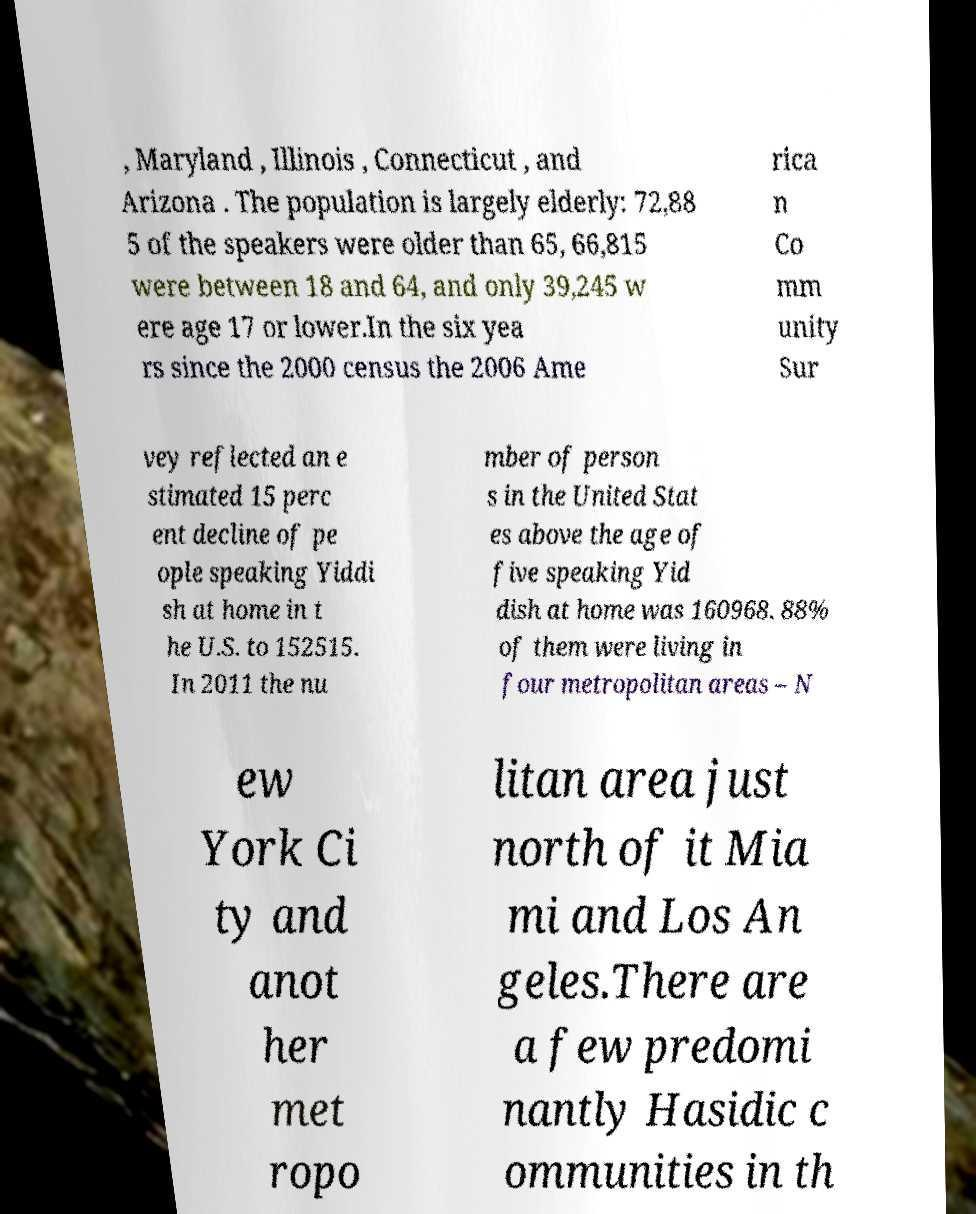Could you extract and type out the text from this image? , Maryland , Illinois , Connecticut , and Arizona . The population is largely elderly: 72,88 5 of the speakers were older than 65, 66,815 were between 18 and 64, and only 39,245 w ere age 17 or lower.In the six yea rs since the 2000 census the 2006 Ame rica n Co mm unity Sur vey reflected an e stimated 15 perc ent decline of pe ople speaking Yiddi sh at home in t he U.S. to 152515. In 2011 the nu mber of person s in the United Stat es above the age of five speaking Yid dish at home was 160968. 88% of them were living in four metropolitan areas – N ew York Ci ty and anot her met ropo litan area just north of it Mia mi and Los An geles.There are a few predomi nantly Hasidic c ommunities in th 